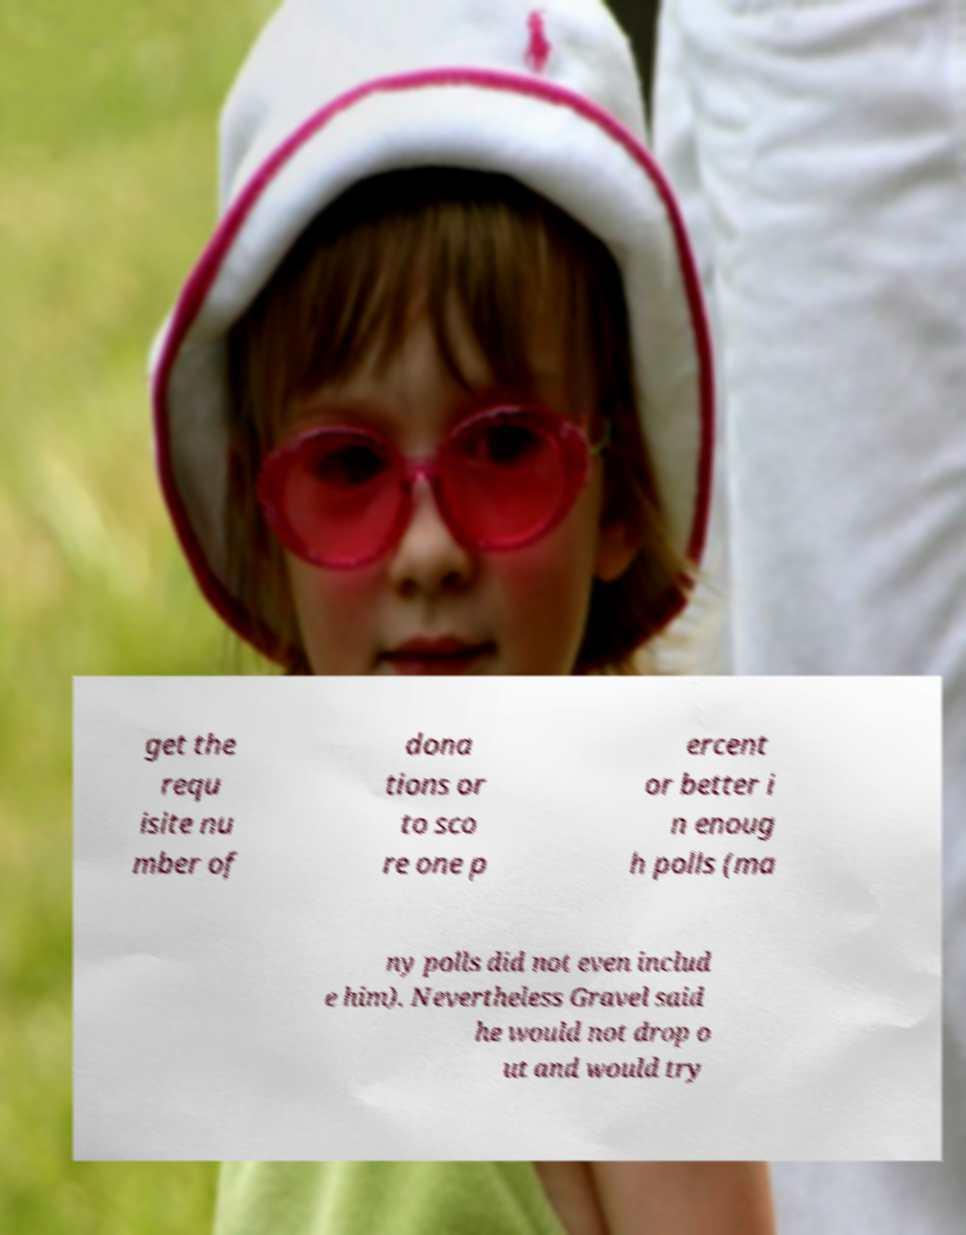Can you read and provide the text displayed in the image?This photo seems to have some interesting text. Can you extract and type it out for me? get the requ isite nu mber of dona tions or to sco re one p ercent or better i n enoug h polls (ma ny polls did not even includ e him). Nevertheless Gravel said he would not drop o ut and would try 